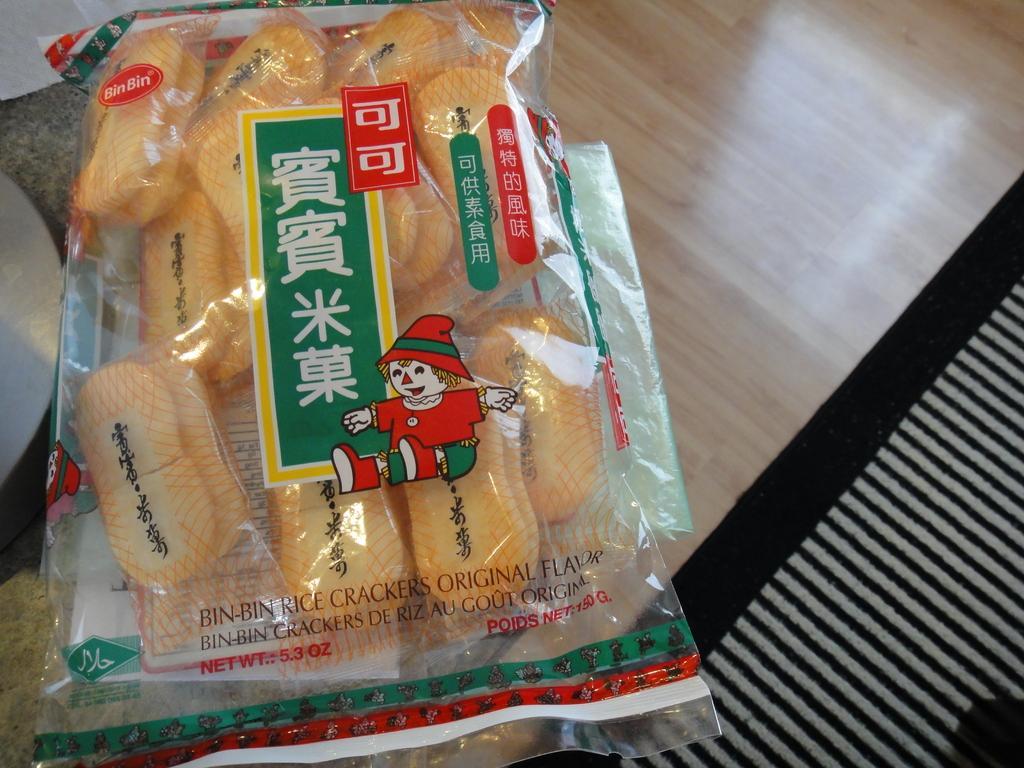Please provide a concise description of this image. Here I can see a table on which a food packet, some papers and cloth are placed. 